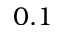Convert formula to latex. <formula><loc_0><loc_0><loc_500><loc_500>0 . 1</formula> 